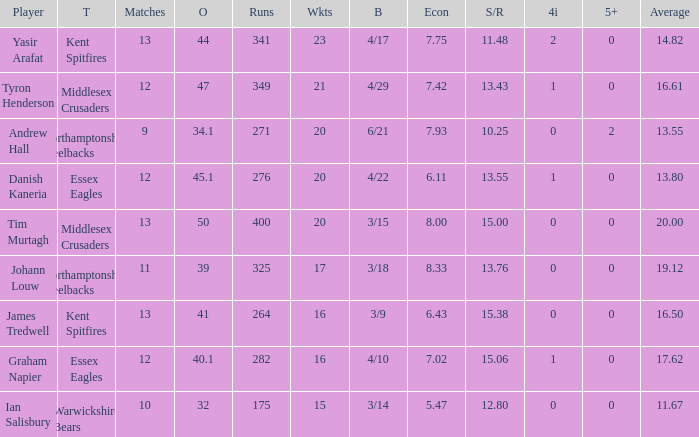Identify the minimum games for achieving 276 runs. 12.0. Would you be able to parse every entry in this table? {'header': ['Player', 'T', 'Matches', 'O', 'Runs', 'Wkts', 'B', 'Econ', 'S/R', '4i', '5+', 'Average'], 'rows': [['Yasir Arafat', 'Kent Spitfires', '13', '44', '341', '23', '4/17', '7.75', '11.48', '2', '0', '14.82'], ['Tyron Henderson', 'Middlesex Crusaders', '12', '47', '349', '21', '4/29', '7.42', '13.43', '1', '0', '16.61'], ['Andrew Hall', 'Northamptonshire Steelbacks', '9', '34.1', '271', '20', '6/21', '7.93', '10.25', '0', '2', '13.55'], ['Danish Kaneria', 'Essex Eagles', '12', '45.1', '276', '20', '4/22', '6.11', '13.55', '1', '0', '13.80'], ['Tim Murtagh', 'Middlesex Crusaders', '13', '50', '400', '20', '3/15', '8.00', '15.00', '0', '0', '20.00'], ['Johann Louw', 'Northamptonshire Steelbacks', '11', '39', '325', '17', '3/18', '8.33', '13.76', '0', '0', '19.12'], ['James Tredwell', 'Kent Spitfires', '13', '41', '264', '16', '3/9', '6.43', '15.38', '0', '0', '16.50'], ['Graham Napier', 'Essex Eagles', '12', '40.1', '282', '16', '4/10', '7.02', '15.06', '1', '0', '17.62'], ['Ian Salisbury', 'Warwickshire Bears', '10', '32', '175', '15', '3/14', '5.47', '12.80', '0', '0', '11.67']]} 